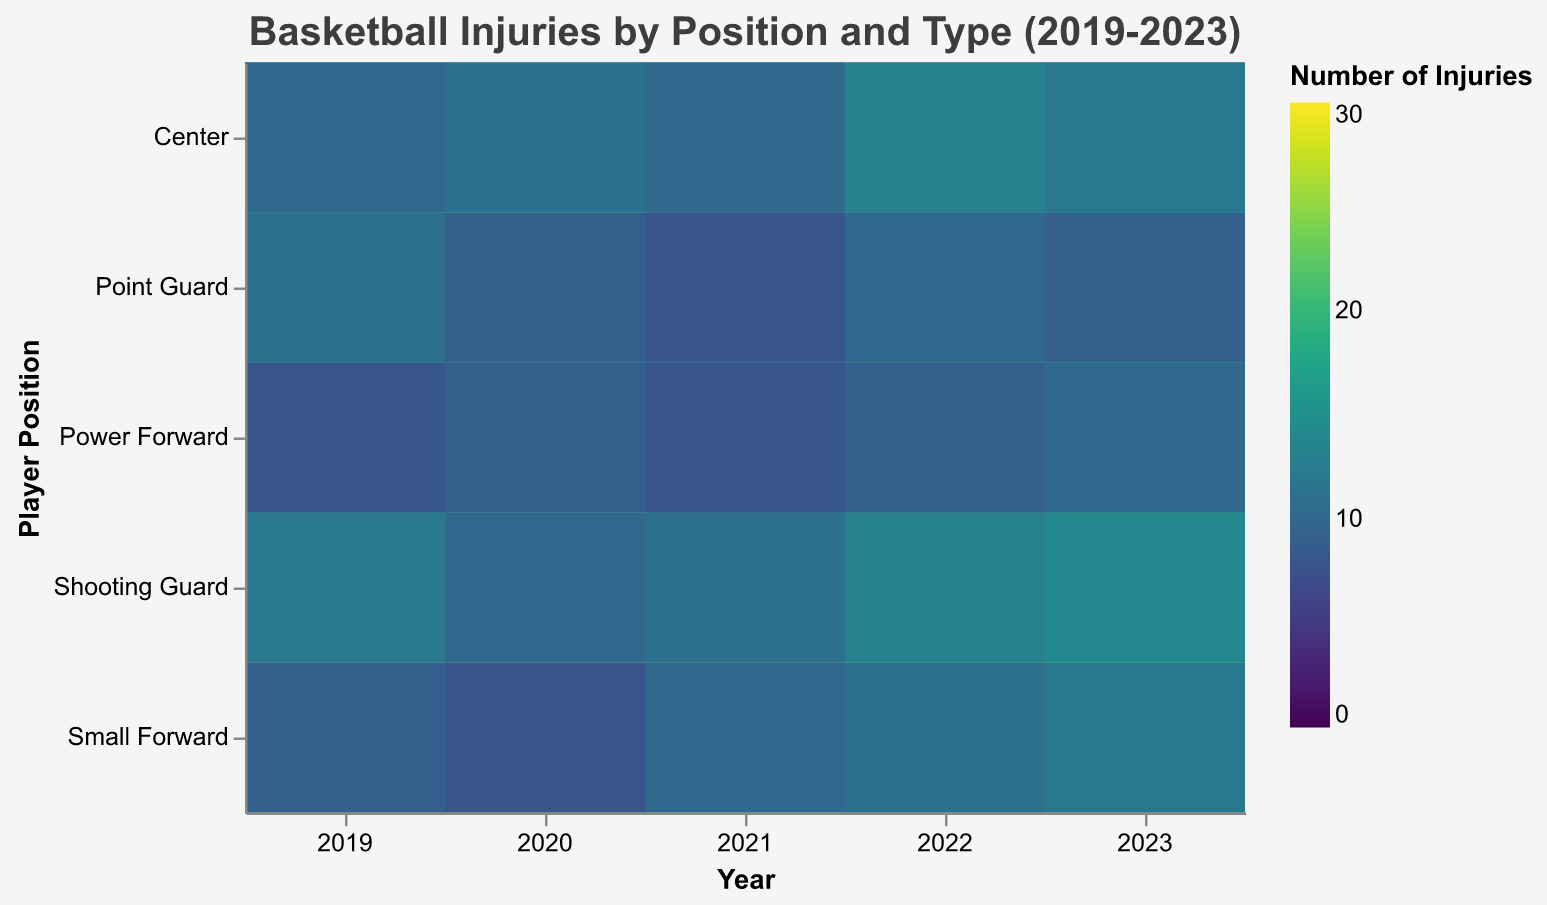Which player position had the most ankle sprains in 2023? Look at the color intensity for ankle sprains across all player positions for the year 2023. The darkest color indicates the highest number of injuries. For 2023, the darkest cell for ankle sprains is in the row for Small Forward.
Answer: Small Forward How did the number of knee injuries for Point Guards in 2022 compare to 2023? Observe the color and tooltip values for knee injuries of Point Guards in 2022 and 2023. In 2022, the color and tooltip show 11 injuries, while in 2023, it shows 13. Compare the values.
Answer: Increased by 2 What is the overall trend for ankle sprains among Power Forwards from 2019 to 2023? Evaluate the color gradient for ankle sprains corresponding to Power Forwards from 2019 to 2023. The color gets progressively darker from 2019 to 2023, suggesting an increase.
Answer: Increasing Which injury type is least common among Small Forwards in 2020? Check the color intensity for each injury type of Small Forwards in 2020. The lightest color represents the least common injury. Shoulder Strain has the lightest color, showing 8 injuries in the tooltip.
Answer: Shoulder Strain What is the average number of shoulder strains for Shooting Guards over the five-year period? Sum the tooltip values for shoulder strains of Shooting Guards from 2019 to 2023 (12, 10, 11, 13, 14). Then, divide the total by 5 to find the average.
Answer: 12 How have knee injuries for Centers changed from 2019 to 2023? Compare the color gradient and tooltip values for knee injuries in the row for Centers from 2019 to 2023. The tooltip shows 18 in 2019 and 15 in 2023, indicating a decrease.
Answer: Decreased Which year had the highest overall number of ankle sprains among all positions? Compare the color intensity for ankle sprains across all positions for each year. The year 2020 has the maximum dark cells, indicating the highest number.
Answer: 2020 Between Point Guards and Shooting Guards, who had a higher average number of shoulder strains in 2021? Compare the tooltip values for shoulder strains in 2021 for Point Guards (8) and Shooting Guards (11). Shooting Guards have a higher average.
Answer: Shooting Guards What is the total number of knee injuries for Small Forwards in 2021 and 2023 combined? Sum the tooltip values for Small Forwards' knee injuries in 2021 (14) and 2023 (18). The total is 14 + 18.
Answer: 32 